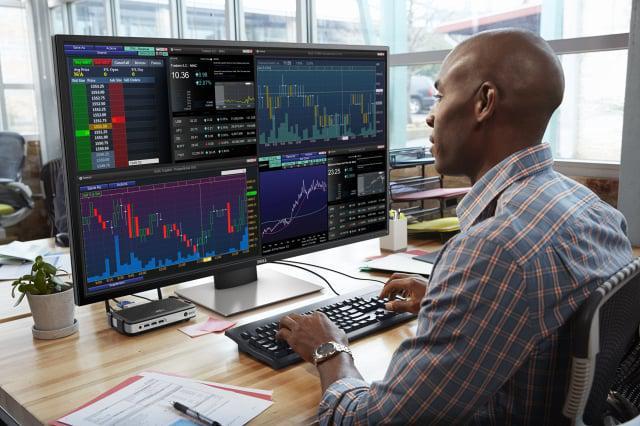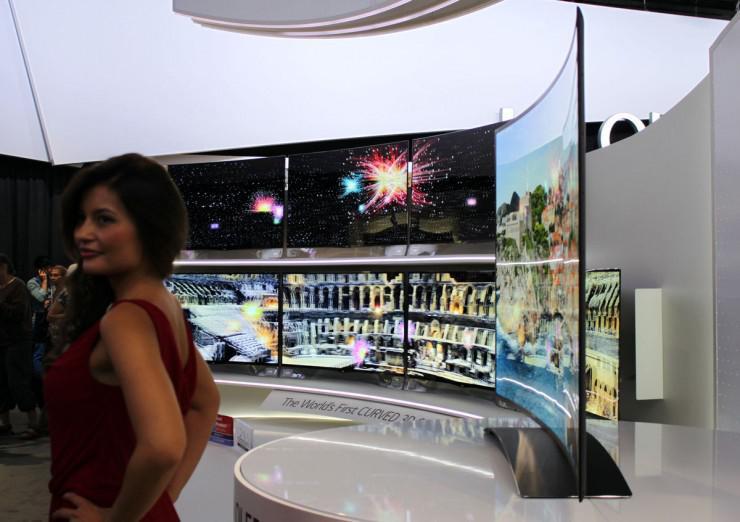The first image is the image on the left, the second image is the image on the right. Assess this claim about the two images: "Atleast one image contains a computer monitor.". Correct or not? Answer yes or no. Yes. The first image is the image on the left, the second image is the image on the right. Analyze the images presented: Is the assertion "There are no women featured in any of the images." valid? Answer yes or no. No. 